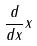Convert formula to latex. <formula><loc_0><loc_0><loc_500><loc_500>\frac { d } { d x } x</formula> 